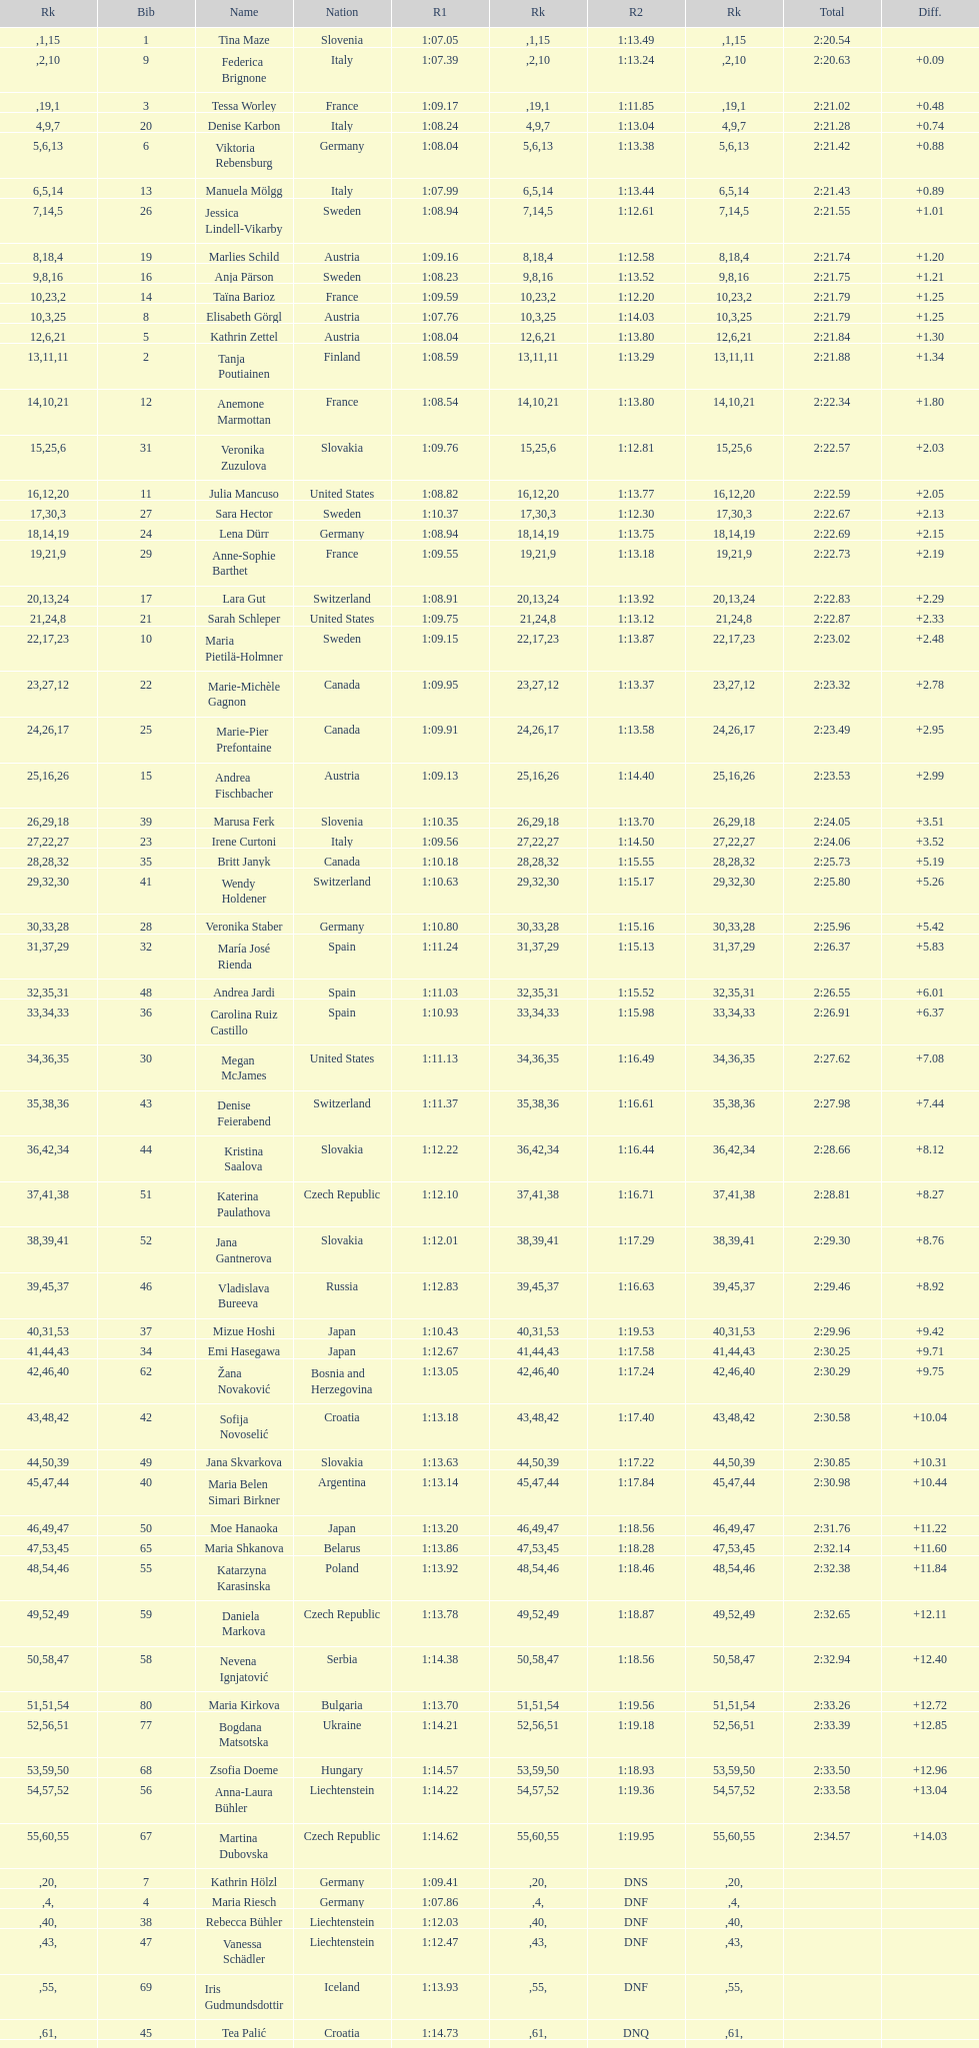What is the name before anja parson? Marlies Schild. 